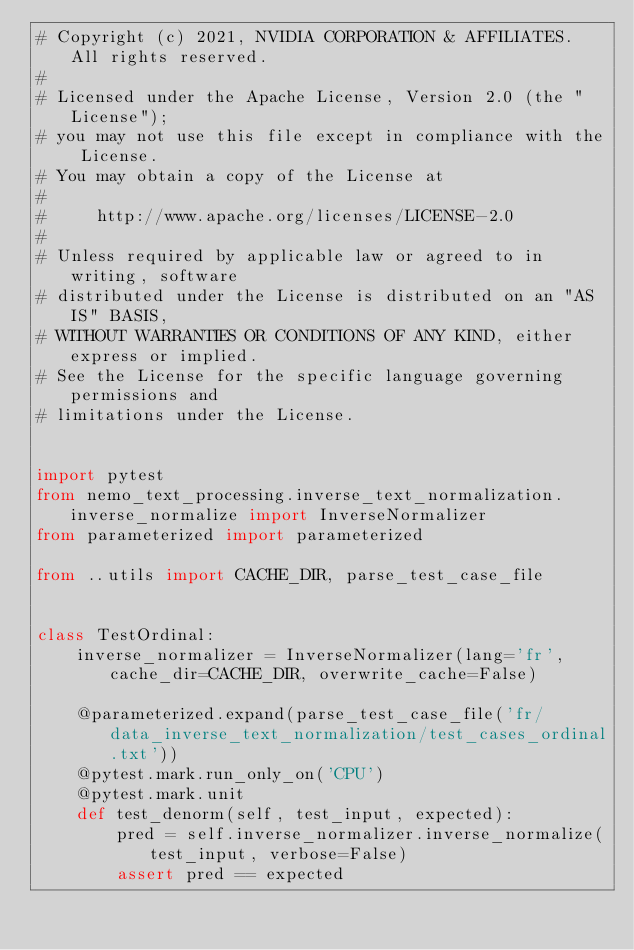Convert code to text. <code><loc_0><loc_0><loc_500><loc_500><_Python_># Copyright (c) 2021, NVIDIA CORPORATION & AFFILIATES.  All rights reserved.
#
# Licensed under the Apache License, Version 2.0 (the "License");
# you may not use this file except in compliance with the License.
# You may obtain a copy of the License at
#
#     http://www.apache.org/licenses/LICENSE-2.0
#
# Unless required by applicable law or agreed to in writing, software
# distributed under the License is distributed on an "AS IS" BASIS,
# WITHOUT WARRANTIES OR CONDITIONS OF ANY KIND, either express or implied.
# See the License for the specific language governing permissions and
# limitations under the License.


import pytest
from nemo_text_processing.inverse_text_normalization.inverse_normalize import InverseNormalizer
from parameterized import parameterized

from ..utils import CACHE_DIR, parse_test_case_file


class TestOrdinal:
    inverse_normalizer = InverseNormalizer(lang='fr', cache_dir=CACHE_DIR, overwrite_cache=False)

    @parameterized.expand(parse_test_case_file('fr/data_inverse_text_normalization/test_cases_ordinal.txt'))
    @pytest.mark.run_only_on('CPU')
    @pytest.mark.unit
    def test_denorm(self, test_input, expected):
        pred = self.inverse_normalizer.inverse_normalize(test_input, verbose=False)
        assert pred == expected
</code> 